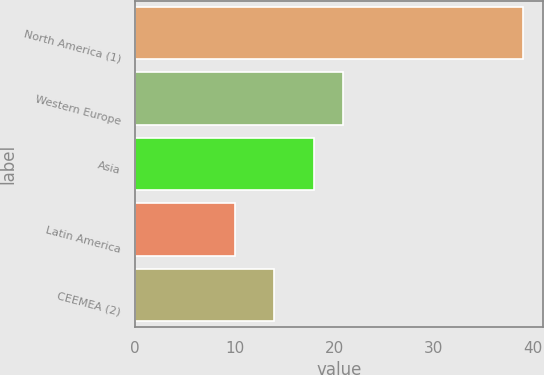<chart> <loc_0><loc_0><loc_500><loc_500><bar_chart><fcel>North America (1)<fcel>Western Europe<fcel>Asia<fcel>Latin America<fcel>CEEMEA (2)<nl><fcel>39<fcel>20.9<fcel>18<fcel>10<fcel>14<nl></chart> 